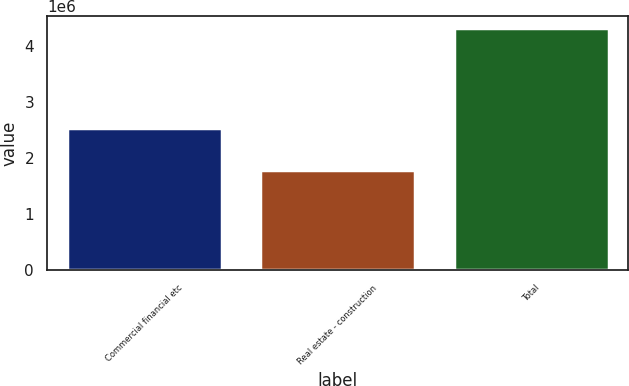Convert chart to OTSL. <chart><loc_0><loc_0><loc_500><loc_500><bar_chart><fcel>Commercial financial etc<fcel>Real estate - construction<fcel>Total<nl><fcel>2.52992e+06<fcel>1.78912e+06<fcel>4.31904e+06<nl></chart> 